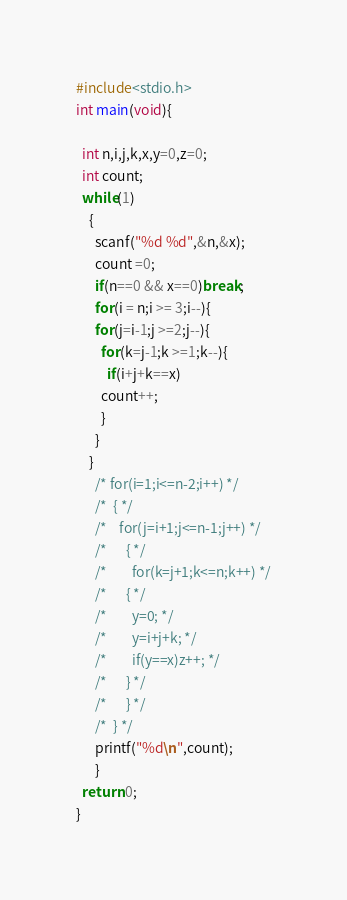<code> <loc_0><loc_0><loc_500><loc_500><_C_>#include<stdio.h>
int main(void){
  
  int n,i,j,k,x,y=0,z=0;
  int count;
  while(1)
    {
      scanf("%d %d",&n,&x);
      count =0;
      if(n==0 && x==0)break;
      for(i = n;i >= 3;i--){
	  for(j=i-1;j >=2;j--){
	    for(k=j-1;k >=1;k--){
	      if(i+j+k==x)
		count++;
	    }
	  }
	}
      /* for(i=1;i<=n-2;i++) */
      /* 	{ */
      /* 	  for(j=i+1;j<=n-1;j++) */
      /* 	    { */
      /* 	      for(k=j+1;k<=n;k++) */
      /* 		{ */
      /* 		  y=0; */
      /* 		  y=i+j+k; */
      /* 		  if(y==x)z++; */
      /* 		} */
      /* 	    } */
      /* 	} */
      printf("%d\n",count);
	  }
  return 0;
}</code> 